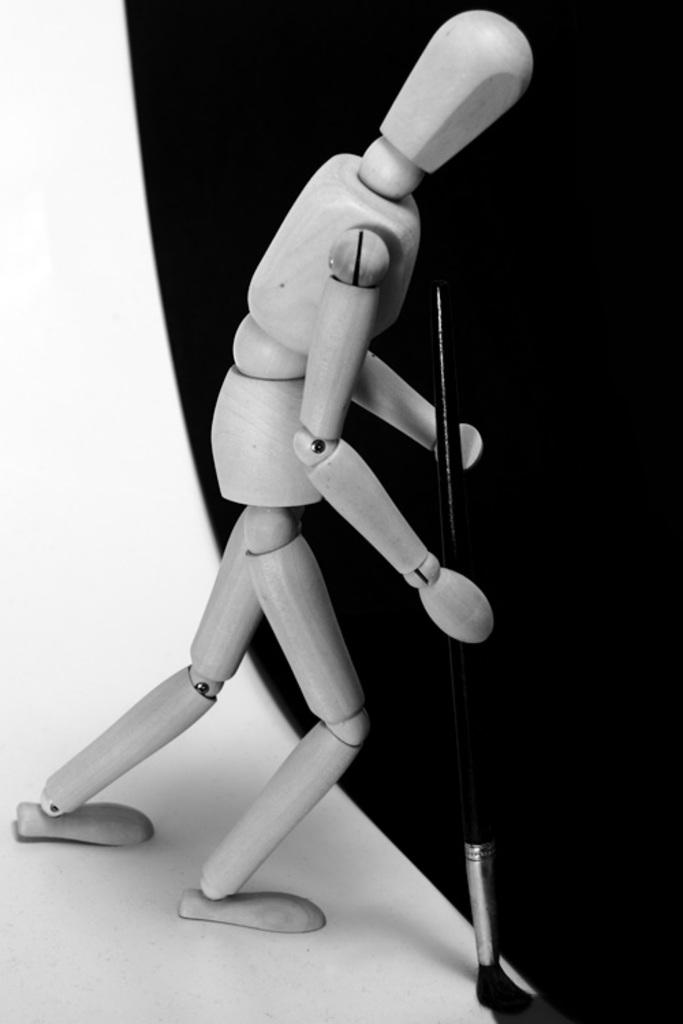What is the color scheme of the image? The image is black and white. What type of object can be seen in the image? There is a toy in the image. What other object is present in the image? There is a brush in the image. On what surface are the objects placed? The objects are on a white surface. Where is the black color visible in the image? The black color is visible on the right side of the image. How many sisters are playing with the toy in the image? There are no sisters present in the image; it only features a toy and a brush on a white surface. Can you see a giraffe wearing a hat in the image? There is no giraffe or hat present in the image. 